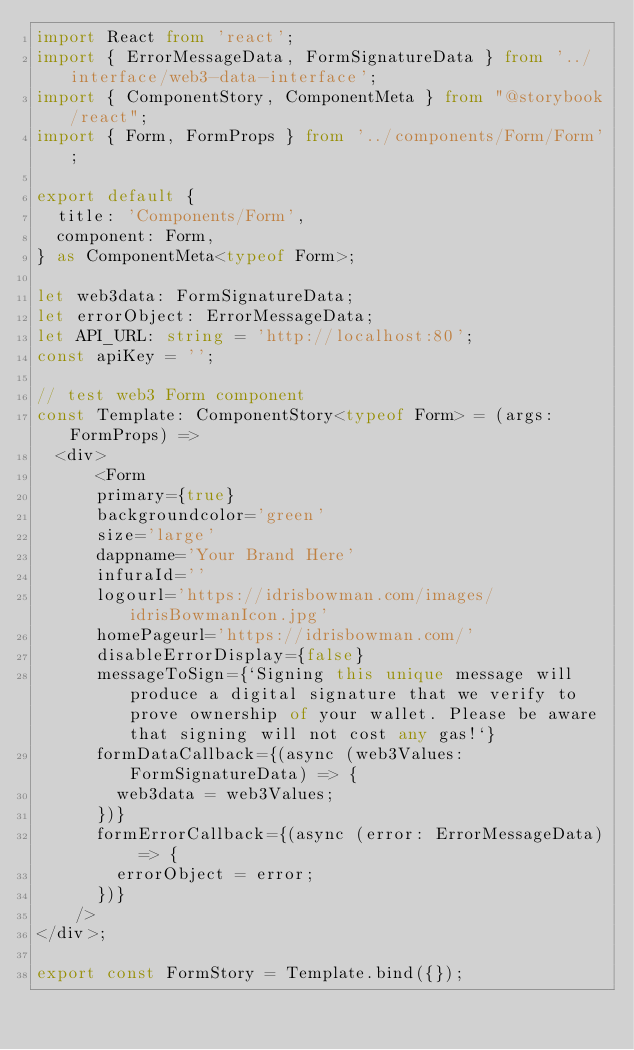Convert code to text. <code><loc_0><loc_0><loc_500><loc_500><_TypeScript_>import React from 'react';
import { ErrorMessageData, FormSignatureData } from '../interface/web3-data-interface';
import { ComponentStory, ComponentMeta } from "@storybook/react";
import { Form, FormProps } from '../components/Form/Form';

export default {
  title: 'Components/Form',
  component: Form,
} as ComponentMeta<typeof Form>;

let web3data: FormSignatureData;
let errorObject: ErrorMessageData;
let API_URL: string = 'http://localhost:80';
const apiKey = '';

// test web3 Form component
const Template: ComponentStory<typeof Form> = (args: FormProps) =>
  <div>
      <Form
      primary={true}
      backgroundcolor='green'
      size='large'
      dappname='Your Brand Here'
      infuraId=''
      logourl='https://idrisbowman.com/images/idrisBowmanIcon.jpg'
      homePageurl='https://idrisbowman.com/'
      disableErrorDisplay={false}
      messageToSign={`Signing this unique message will produce a digital signature that we verify to prove ownership of your wallet. Please be aware that signing will not cost any gas!`}
      formDataCallback={(async (web3Values: FormSignatureData) => {
        web3data = web3Values;
      })}
      formErrorCallback={(async (error: ErrorMessageData) => {
        errorObject = error;
      })}   
    />
</div>;
 
export const FormStory = Template.bind({});
</code> 